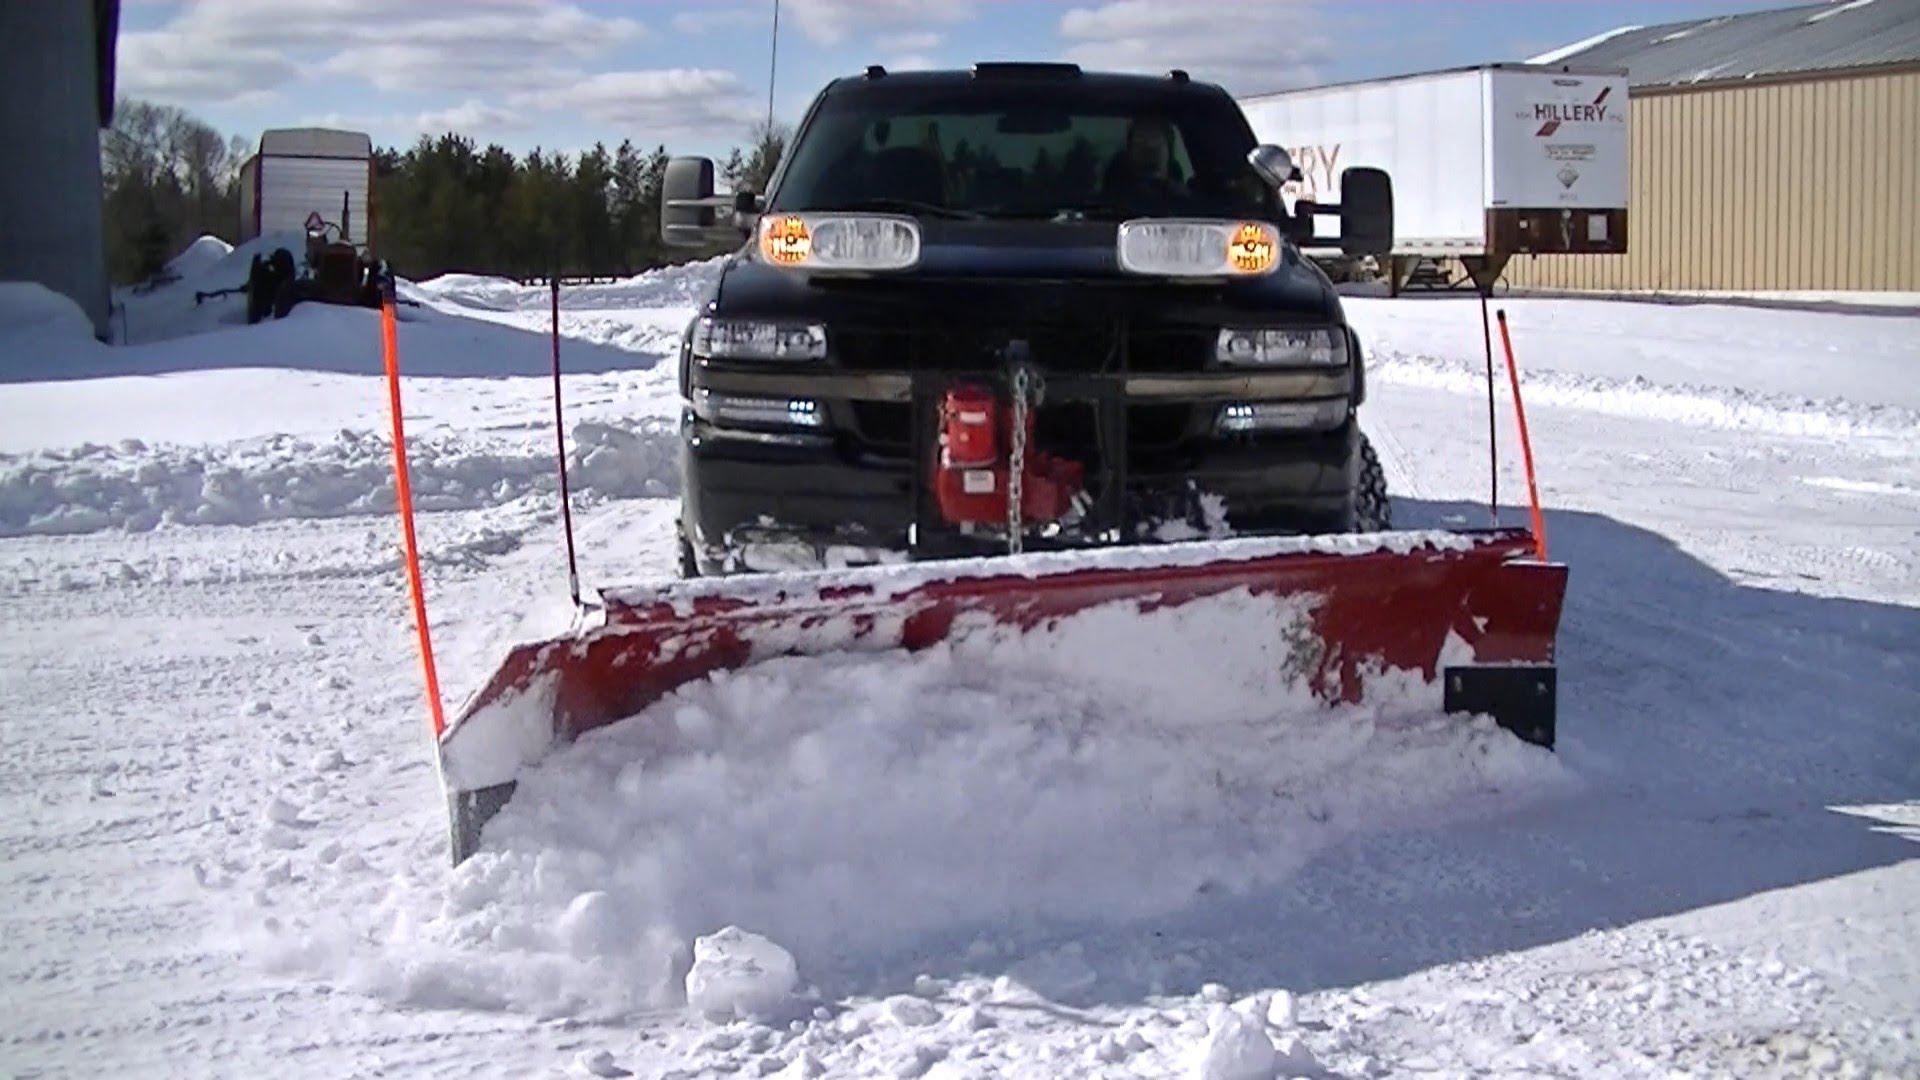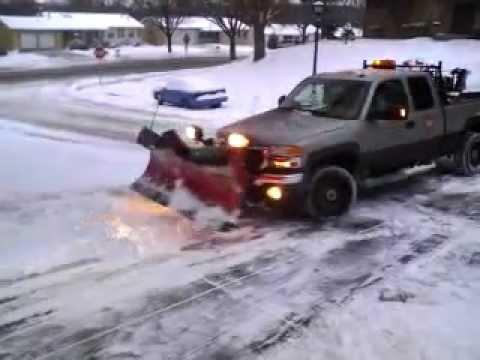The first image is the image on the left, the second image is the image on the right. For the images displayed, is the sentence "At least one of the images shows a highway scene." factually correct? Answer yes or no. No. 